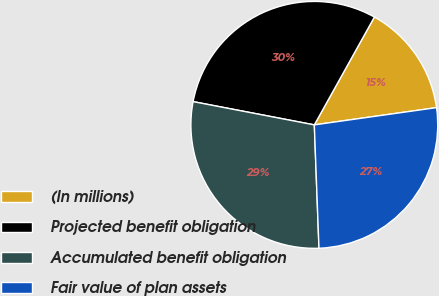<chart> <loc_0><loc_0><loc_500><loc_500><pie_chart><fcel>(In millions)<fcel>Projected benefit obligation<fcel>Accumulated benefit obligation<fcel>Fair value of plan assets<nl><fcel>14.68%<fcel>30.07%<fcel>28.62%<fcel>26.63%<nl></chart> 